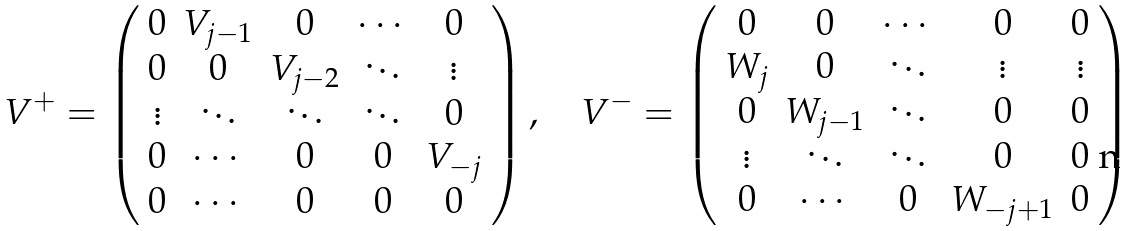Convert formula to latex. <formula><loc_0><loc_0><loc_500><loc_500>V ^ { + } = \left ( \begin{array} { c c c c c } 0 & V _ { j - 1 } & 0 & \cdots & 0 \\ 0 & 0 & V _ { j - 2 } & \ddots & \vdots \\ \vdots & \ddots & \ddots & \ddots & 0 \\ 0 & \cdots & 0 & 0 & V _ { - j } \\ 0 & \cdots & 0 & 0 & 0 \end{array} \right ) , \quad V ^ { - } = \left ( \begin{array} { c c c c c } 0 & 0 & \cdots & 0 & 0 \\ W _ { j } & 0 & \ddots & \vdots & \vdots \\ 0 & W _ { j - 1 } & \ddots & 0 & 0 \\ \vdots & \ddots & \ddots & 0 & 0 \\ 0 & \cdots & 0 & W _ { - j + 1 } & 0 \end{array} \right )</formula> 